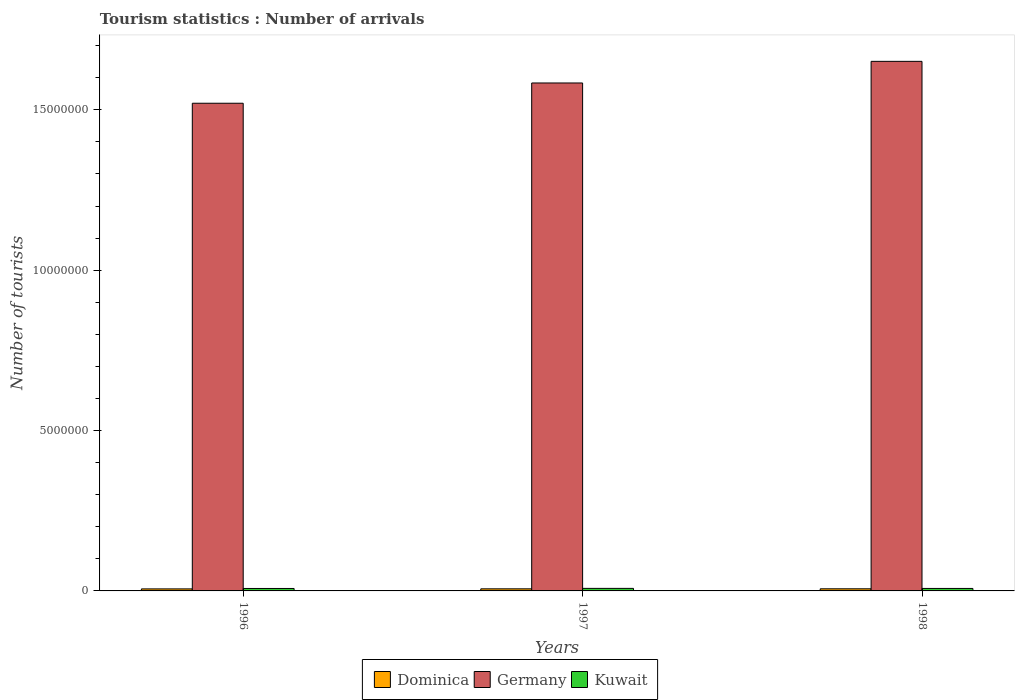How many bars are there on the 1st tick from the right?
Give a very brief answer. 3. What is the number of tourist arrivals in Kuwait in 1997?
Your answer should be compact. 7.90e+04. Across all years, what is the maximum number of tourist arrivals in Dominica?
Your answer should be very brief. 6.60e+04. Across all years, what is the minimum number of tourist arrivals in Kuwait?
Give a very brief answer. 7.60e+04. In which year was the number of tourist arrivals in Kuwait maximum?
Your response must be concise. 1997. In which year was the number of tourist arrivals in Dominica minimum?
Keep it short and to the point. 1996. What is the total number of tourist arrivals in Kuwait in the graph?
Provide a short and direct response. 2.32e+05. What is the difference between the number of tourist arrivals in Dominica in 1996 and that in 1997?
Provide a succinct answer. -2000. What is the difference between the number of tourist arrivals in Germany in 1997 and the number of tourist arrivals in Kuwait in 1996?
Give a very brief answer. 1.58e+07. What is the average number of tourist arrivals in Kuwait per year?
Your answer should be very brief. 7.73e+04. In the year 1996, what is the difference between the number of tourist arrivals in Germany and number of tourist arrivals in Kuwait?
Give a very brief answer. 1.51e+07. What is the ratio of the number of tourist arrivals in Dominica in 1996 to that in 1997?
Offer a terse response. 0.97. Is the difference between the number of tourist arrivals in Germany in 1996 and 1998 greater than the difference between the number of tourist arrivals in Kuwait in 1996 and 1998?
Keep it short and to the point. No. What is the difference between the highest and the second highest number of tourist arrivals in Germany?
Make the answer very short. 6.74e+05. What is the difference between the highest and the lowest number of tourist arrivals in Kuwait?
Offer a terse response. 3000. What does the 3rd bar from the left in 1996 represents?
Ensure brevity in your answer.  Kuwait. What does the 1st bar from the right in 1998 represents?
Keep it short and to the point. Kuwait. How many bars are there?
Your answer should be very brief. 9. What is the difference between two consecutive major ticks on the Y-axis?
Your answer should be very brief. 5.00e+06. How many legend labels are there?
Keep it short and to the point. 3. How are the legend labels stacked?
Your answer should be very brief. Horizontal. What is the title of the graph?
Keep it short and to the point. Tourism statistics : Number of arrivals. Does "Uzbekistan" appear as one of the legend labels in the graph?
Provide a succinct answer. No. What is the label or title of the Y-axis?
Make the answer very short. Number of tourists. What is the Number of tourists in Dominica in 1996?
Offer a very short reply. 6.30e+04. What is the Number of tourists of Germany in 1996?
Your response must be concise. 1.52e+07. What is the Number of tourists of Kuwait in 1996?
Your answer should be very brief. 7.60e+04. What is the Number of tourists of Dominica in 1997?
Your response must be concise. 6.50e+04. What is the Number of tourists in Germany in 1997?
Your response must be concise. 1.58e+07. What is the Number of tourists in Kuwait in 1997?
Keep it short and to the point. 7.90e+04. What is the Number of tourists in Dominica in 1998?
Provide a short and direct response. 6.60e+04. What is the Number of tourists of Germany in 1998?
Keep it short and to the point. 1.65e+07. What is the Number of tourists of Kuwait in 1998?
Ensure brevity in your answer.  7.70e+04. Across all years, what is the maximum Number of tourists in Dominica?
Give a very brief answer. 6.60e+04. Across all years, what is the maximum Number of tourists of Germany?
Your response must be concise. 1.65e+07. Across all years, what is the maximum Number of tourists of Kuwait?
Your response must be concise. 7.90e+04. Across all years, what is the minimum Number of tourists in Dominica?
Your answer should be very brief. 6.30e+04. Across all years, what is the minimum Number of tourists in Germany?
Give a very brief answer. 1.52e+07. Across all years, what is the minimum Number of tourists in Kuwait?
Offer a very short reply. 7.60e+04. What is the total Number of tourists in Dominica in the graph?
Ensure brevity in your answer.  1.94e+05. What is the total Number of tourists of Germany in the graph?
Your answer should be compact. 4.76e+07. What is the total Number of tourists in Kuwait in the graph?
Your response must be concise. 2.32e+05. What is the difference between the Number of tourists in Dominica in 1996 and that in 1997?
Provide a succinct answer. -2000. What is the difference between the Number of tourists in Germany in 1996 and that in 1997?
Offer a very short reply. -6.32e+05. What is the difference between the Number of tourists in Kuwait in 1996 and that in 1997?
Provide a short and direct response. -3000. What is the difference between the Number of tourists in Dominica in 1996 and that in 1998?
Provide a short and direct response. -3000. What is the difference between the Number of tourists in Germany in 1996 and that in 1998?
Your answer should be very brief. -1.31e+06. What is the difference between the Number of tourists of Kuwait in 1996 and that in 1998?
Provide a short and direct response. -1000. What is the difference between the Number of tourists of Dominica in 1997 and that in 1998?
Provide a succinct answer. -1000. What is the difference between the Number of tourists of Germany in 1997 and that in 1998?
Keep it short and to the point. -6.74e+05. What is the difference between the Number of tourists of Kuwait in 1997 and that in 1998?
Make the answer very short. 2000. What is the difference between the Number of tourists of Dominica in 1996 and the Number of tourists of Germany in 1997?
Give a very brief answer. -1.58e+07. What is the difference between the Number of tourists in Dominica in 1996 and the Number of tourists in Kuwait in 1997?
Offer a very short reply. -1.60e+04. What is the difference between the Number of tourists of Germany in 1996 and the Number of tourists of Kuwait in 1997?
Give a very brief answer. 1.51e+07. What is the difference between the Number of tourists in Dominica in 1996 and the Number of tourists in Germany in 1998?
Provide a succinct answer. -1.64e+07. What is the difference between the Number of tourists in Dominica in 1996 and the Number of tourists in Kuwait in 1998?
Your answer should be very brief. -1.40e+04. What is the difference between the Number of tourists in Germany in 1996 and the Number of tourists in Kuwait in 1998?
Your answer should be compact. 1.51e+07. What is the difference between the Number of tourists of Dominica in 1997 and the Number of tourists of Germany in 1998?
Offer a very short reply. -1.64e+07. What is the difference between the Number of tourists of Dominica in 1997 and the Number of tourists of Kuwait in 1998?
Ensure brevity in your answer.  -1.20e+04. What is the difference between the Number of tourists in Germany in 1997 and the Number of tourists in Kuwait in 1998?
Your response must be concise. 1.58e+07. What is the average Number of tourists in Dominica per year?
Offer a very short reply. 6.47e+04. What is the average Number of tourists of Germany per year?
Provide a succinct answer. 1.59e+07. What is the average Number of tourists in Kuwait per year?
Provide a succinct answer. 7.73e+04. In the year 1996, what is the difference between the Number of tourists of Dominica and Number of tourists of Germany?
Offer a terse response. -1.51e+07. In the year 1996, what is the difference between the Number of tourists in Dominica and Number of tourists in Kuwait?
Provide a succinct answer. -1.30e+04. In the year 1996, what is the difference between the Number of tourists in Germany and Number of tourists in Kuwait?
Give a very brief answer. 1.51e+07. In the year 1997, what is the difference between the Number of tourists in Dominica and Number of tourists in Germany?
Keep it short and to the point. -1.58e+07. In the year 1997, what is the difference between the Number of tourists in Dominica and Number of tourists in Kuwait?
Give a very brief answer. -1.40e+04. In the year 1997, what is the difference between the Number of tourists in Germany and Number of tourists in Kuwait?
Your response must be concise. 1.58e+07. In the year 1998, what is the difference between the Number of tourists in Dominica and Number of tourists in Germany?
Your answer should be very brief. -1.64e+07. In the year 1998, what is the difference between the Number of tourists in Dominica and Number of tourists in Kuwait?
Offer a terse response. -1.10e+04. In the year 1998, what is the difference between the Number of tourists of Germany and Number of tourists of Kuwait?
Keep it short and to the point. 1.64e+07. What is the ratio of the Number of tourists in Dominica in 1996 to that in 1997?
Offer a terse response. 0.97. What is the ratio of the Number of tourists of Germany in 1996 to that in 1997?
Offer a terse response. 0.96. What is the ratio of the Number of tourists in Kuwait in 1996 to that in 1997?
Provide a succinct answer. 0.96. What is the ratio of the Number of tourists of Dominica in 1996 to that in 1998?
Offer a very short reply. 0.95. What is the ratio of the Number of tourists in Germany in 1996 to that in 1998?
Your response must be concise. 0.92. What is the ratio of the Number of tourists in Germany in 1997 to that in 1998?
Keep it short and to the point. 0.96. What is the difference between the highest and the second highest Number of tourists of Dominica?
Give a very brief answer. 1000. What is the difference between the highest and the second highest Number of tourists of Germany?
Offer a very short reply. 6.74e+05. What is the difference between the highest and the lowest Number of tourists of Dominica?
Keep it short and to the point. 3000. What is the difference between the highest and the lowest Number of tourists of Germany?
Your answer should be very brief. 1.31e+06. What is the difference between the highest and the lowest Number of tourists in Kuwait?
Offer a very short reply. 3000. 